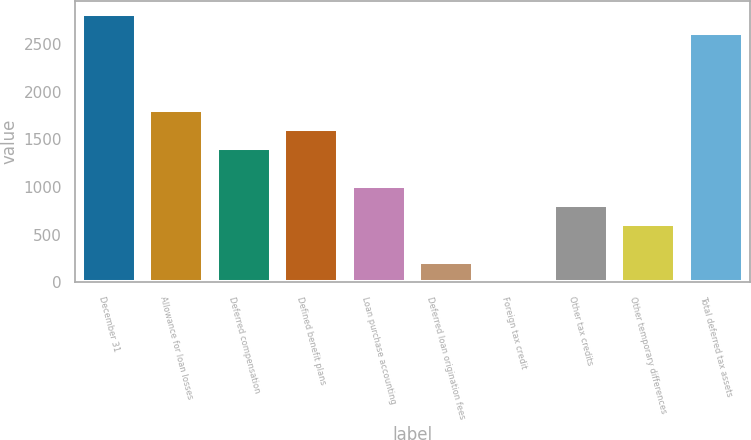Convert chart. <chart><loc_0><loc_0><loc_500><loc_500><bar_chart><fcel>December 31<fcel>Allowance for loan losses<fcel>Deferred compensation<fcel>Defined benefit plans<fcel>Loan purchase accounting<fcel>Deferred loan origination fees<fcel>Foreign tax credit<fcel>Other tax credits<fcel>Other temporary differences<fcel>Total deferred tax assets<nl><fcel>2809.8<fcel>1811.3<fcel>1411.9<fcel>1611.6<fcel>1012.5<fcel>213.7<fcel>14<fcel>812.8<fcel>613.1<fcel>2610.1<nl></chart> 